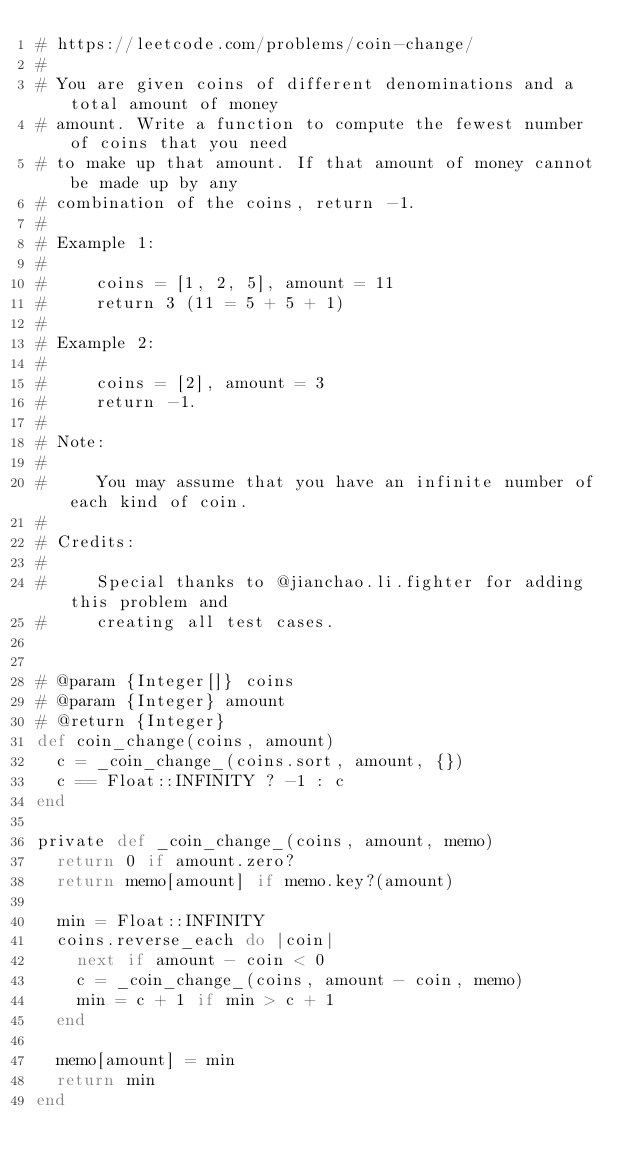<code> <loc_0><loc_0><loc_500><loc_500><_Ruby_># https://leetcode.com/problems/coin-change/
#
# You are given coins of different denominations and a total amount of money
# amount. Write a function to compute the fewest number of coins that you need
# to make up that amount. If that amount of money cannot be made up by any
# combination of the coins, return -1.
#
# Example 1:
#
#     coins = [1, 2, 5], amount = 11
#     return 3 (11 = 5 + 5 + 1)
#
# Example 2:
#
#     coins = [2], amount = 3
#     return -1.
#
# Note:
#
#     You may assume that you have an infinite number of each kind of coin.
#
# Credits:
#
#     Special thanks to @jianchao.li.fighter for adding this problem and
#     creating all test cases.


# @param {Integer[]} coins
# @param {Integer} amount
# @return {Integer}
def coin_change(coins, amount)
  c = _coin_change_(coins.sort, amount, {})
  c == Float::INFINITY ? -1 : c
end

private def _coin_change_(coins, amount, memo)
  return 0 if amount.zero?
  return memo[amount] if memo.key?(amount)

  min = Float::INFINITY
  coins.reverse_each do |coin|
    next if amount - coin < 0
    c = _coin_change_(coins, amount - coin, memo)
    min = c + 1 if min > c + 1
  end

  memo[amount] = min
  return min
end
</code> 